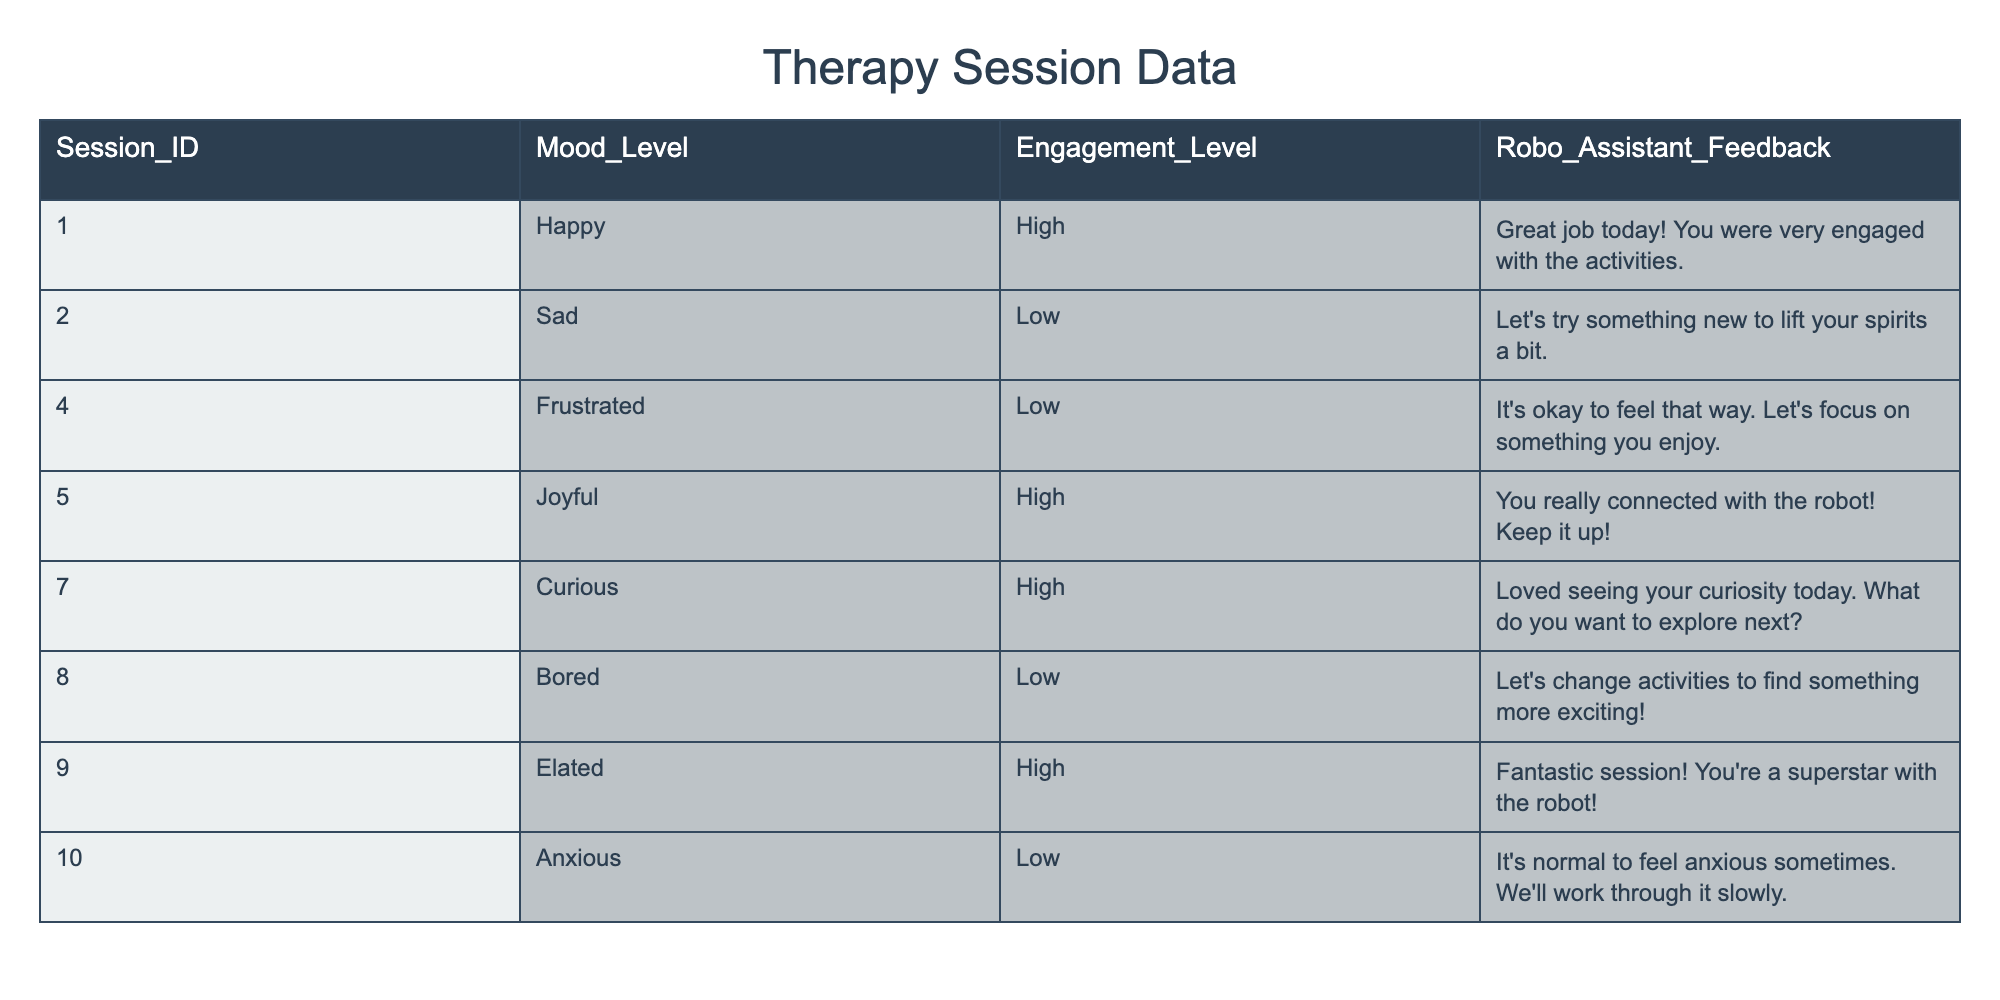What mood level was recorded during session 10? The table shows that in session 10, the mood level recorded was "Anxious."
Answer: Anxious How many therapy sessions had a "High" engagement level? By reviewing the table, I find that sessions 1, 5, 7, and 9 all had a "High" engagement level, which totals to 4 sessions.
Answer: 4 Was the mood level in session 4 "Frustrated"? The table confirms that in session 4, the mood level was indeed "Frustrated."
Answer: Yes What feedback was given during the session with a "Sad" mood level? Looking at the table, the feedback given during the session with a "Sad" mood level (session 2) was "Let's try something new to lift your spirits a bit."
Answer: Let's try something new to lift your spirits a bit How many sessions had a "Low" engagement level and also a "Sad" mood? The table shows that sessions 2, 4, 8, and 10 had a "Low" engagement level. Among these, only session 2 had a mood level classified as "Sad." Thus, there is only 1 session with these criteria.
Answer: 1 What was the mood level during the session with the highest engagement feedback? Referring to the table, session 9 received feedback stating "Fantastic session! You're a superstar with the robot!" indicating high engagement. The mood recorded in that session was "Elated."
Answer: Elated Which session had a "Bored" mood and what was the engagement level? The table shows that session 8 had a "Bored" mood level, and its engagement level was "Low."
Answer: Low What is the difference in the number of sessions with "High" engagement versus "Low" engagement? There were 4 sessions with "High" engagement (1, 5, 7, and 9) and 4 sessions with "Low" engagement (2, 4, 8, and 10). Thus, the difference is 4 - 4 = 0.
Answer: 0 Which session had feedback indicating the person's anxiety? The table indicates that the session with feedback about anxiety was session 10, which mentioned "It's normal to feel anxious sometimes. We'll work through it slowly."
Answer: Session 10 How many positive moods (Happy, Joyful, Curious, Elated) were recorded in total? By analyzing the table, the positive moods are found in sessions 1 (Happy), 5 (Joyful), 7 (Curious), and 9 (Elated), summing to 4 positive moods across the sessions.
Answer: 4 